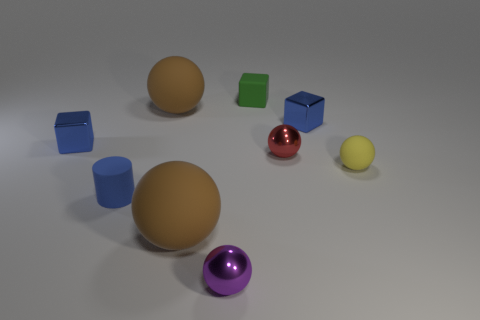Subtract all red spheres. How many spheres are left? 4 Subtract all red blocks. How many brown balls are left? 2 Subtract all red balls. How many balls are left? 4 Subtract all cylinders. How many objects are left? 8 Add 2 tiny blue metallic things. How many tiny blue metallic things are left? 4 Add 8 big rubber things. How many big rubber things exist? 10 Subtract 0 blue spheres. How many objects are left? 9 Subtract 1 cubes. How many cubes are left? 2 Subtract all green cylinders. Subtract all brown balls. How many cylinders are left? 1 Subtract all small yellow blocks. Subtract all purple objects. How many objects are left? 8 